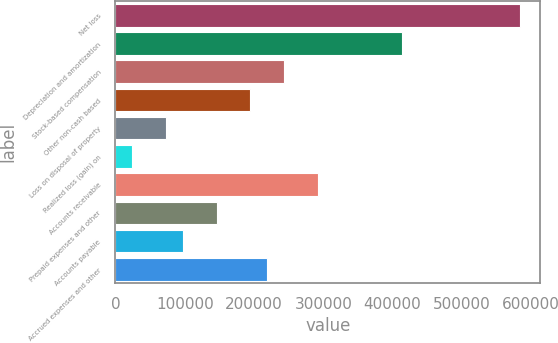Convert chart. <chart><loc_0><loc_0><loc_500><loc_500><bar_chart><fcel>Net loss<fcel>Depreciation and amortization<fcel>Stock-based compensation<fcel>Other non-cash based<fcel>Loss on disposal of property<fcel>Realized loss (gain) on<fcel>Accounts receivable<fcel>Prepaid expenses and other<fcel>Accounts payable<fcel>Accrued expenses and other<nl><fcel>584101<fcel>413756<fcel>243410<fcel>194740<fcel>73064.3<fcel>24394.1<fcel>292080<fcel>146070<fcel>97399.4<fcel>219075<nl></chart> 